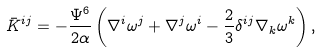Convert formula to latex. <formula><loc_0><loc_0><loc_500><loc_500>\bar { K } ^ { i j } = - \frac { \Psi ^ { 6 } } { 2 \alpha } \left ( \nabla ^ { i } \omega ^ { j } + \nabla ^ { j } \omega ^ { i } - \frac { 2 } { 3 } \delta ^ { i j } \nabla _ { k } \omega ^ { k } \right ) ,</formula> 